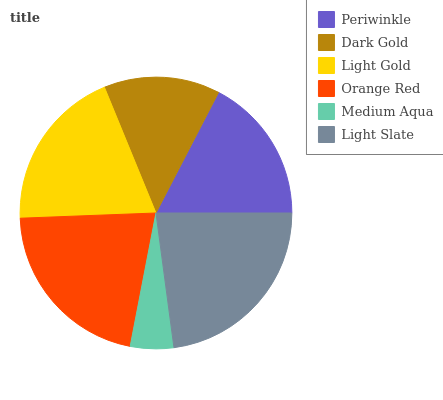Is Medium Aqua the minimum?
Answer yes or no. Yes. Is Light Slate the maximum?
Answer yes or no. Yes. Is Dark Gold the minimum?
Answer yes or no. No. Is Dark Gold the maximum?
Answer yes or no. No. Is Periwinkle greater than Dark Gold?
Answer yes or no. Yes. Is Dark Gold less than Periwinkle?
Answer yes or no. Yes. Is Dark Gold greater than Periwinkle?
Answer yes or no. No. Is Periwinkle less than Dark Gold?
Answer yes or no. No. Is Light Gold the high median?
Answer yes or no. Yes. Is Periwinkle the low median?
Answer yes or no. Yes. Is Light Slate the high median?
Answer yes or no. No. Is Light Gold the low median?
Answer yes or no. No. 